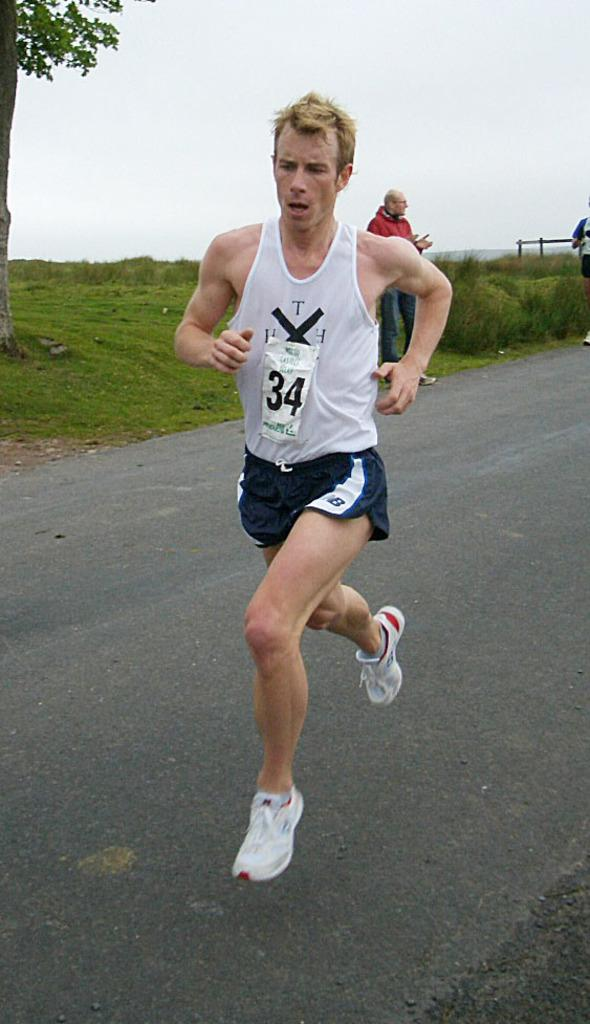<image>
Summarize the visual content of the image. A man running with a white and blue unifom with the number 34 on his mid sectin. 